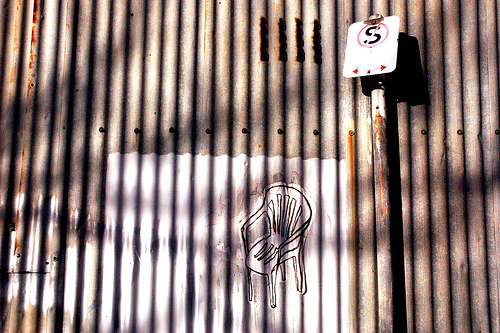<image>
Can you confirm if the chair is in the fence? Yes. The chair is contained within or inside the fence, showing a containment relationship. 